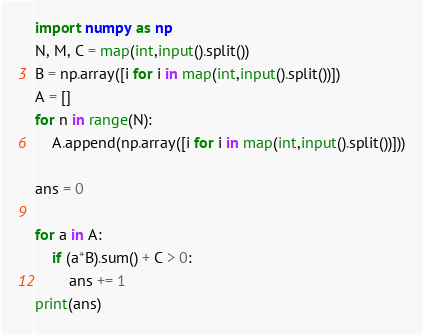Convert code to text. <code><loc_0><loc_0><loc_500><loc_500><_Python_>import numpy as np
N, M, C = map(int,input().split())
B = np.array([i for i in map(int,input().split())])
A = []
for n in range(N):
    A.append(np.array([i for i in map(int,input().split())]))

ans = 0

for a in A:
    if (a*B).sum() + C > 0:
        ans += 1
print(ans)
</code> 